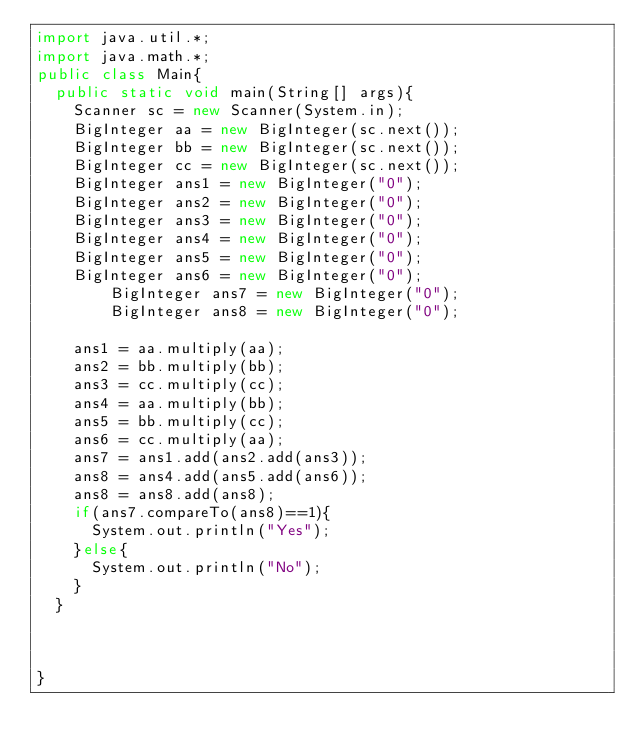Convert code to text. <code><loc_0><loc_0><loc_500><loc_500><_Java_>import java.util.*;
import java.math.*;
public class Main{
  public static void main(String[] args){
    Scanner sc = new Scanner(System.in);
    BigInteger aa = new BigInteger(sc.next());
    BigInteger bb = new BigInteger(sc.next());
    BigInteger cc = new BigInteger(sc.next());
    BigInteger ans1 = new BigInteger("0");
    BigInteger ans2 = new BigInteger("0");
    BigInteger ans3 = new BigInteger("0");
    BigInteger ans4 = new BigInteger("0");
    BigInteger ans5 = new BigInteger("0");
    BigInteger ans6 = new BigInteger("0");
        BigInteger ans7 = new BigInteger("0");
        BigInteger ans8 = new BigInteger("0");
        
    ans1 = aa.multiply(aa);
    ans2 = bb.multiply(bb);
    ans3 = cc.multiply(cc);
    ans4 = aa.multiply(bb);
    ans5 = bb.multiply(cc);
    ans6 = cc.multiply(aa);
    ans7 = ans1.add(ans2.add(ans3));
    ans8 = ans4.add(ans5.add(ans6));
    ans8 = ans8.add(ans8);
    if(ans7.compareTo(ans8)==1){
      System.out.println("Yes");
    }else{
      System.out.println("No");
    }
  }
  

  
}
</code> 